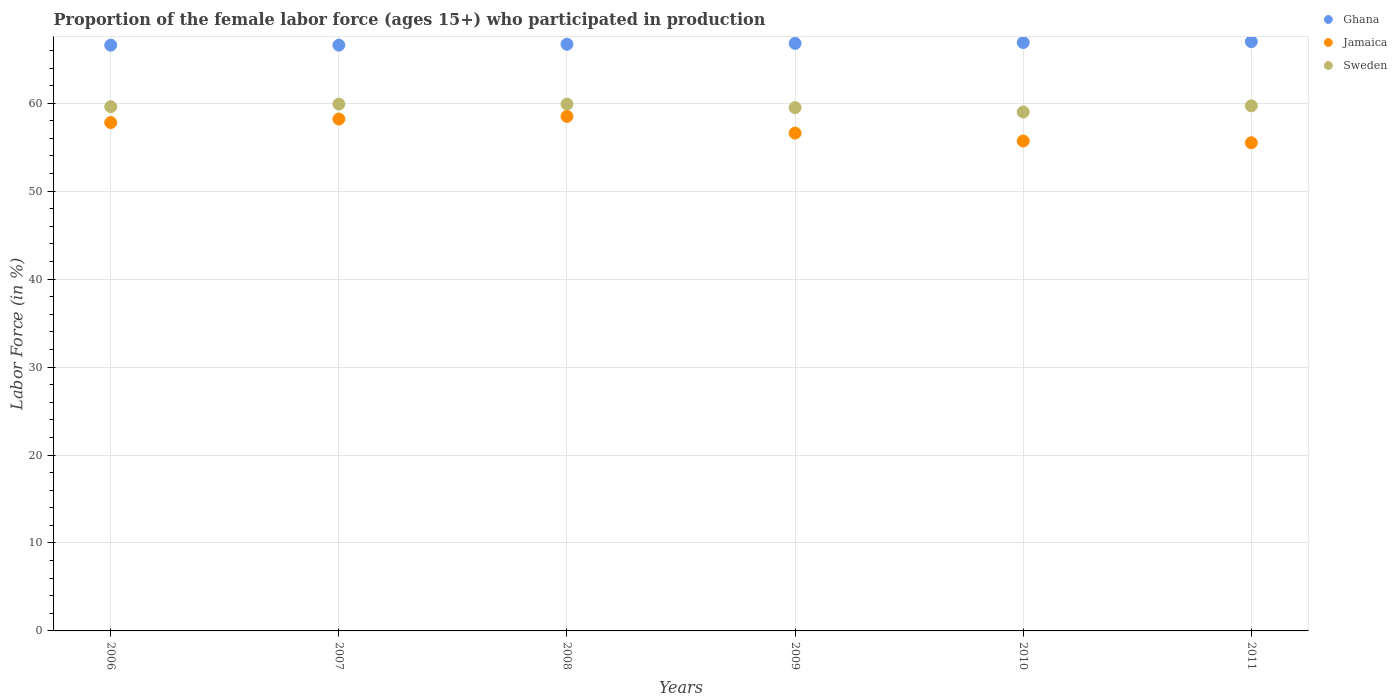Is the number of dotlines equal to the number of legend labels?
Your answer should be very brief. Yes. Across all years, what is the maximum proportion of the female labor force who participated in production in Jamaica?
Provide a short and direct response. 58.5. Across all years, what is the minimum proportion of the female labor force who participated in production in Sweden?
Provide a succinct answer. 59. What is the total proportion of the female labor force who participated in production in Ghana in the graph?
Your response must be concise. 400.6. What is the difference between the proportion of the female labor force who participated in production in Ghana in 2006 and that in 2011?
Give a very brief answer. -0.4. What is the difference between the proportion of the female labor force who participated in production in Jamaica in 2010 and the proportion of the female labor force who participated in production in Ghana in 2008?
Keep it short and to the point. -11. What is the average proportion of the female labor force who participated in production in Sweden per year?
Keep it short and to the point. 59.6. In the year 2009, what is the difference between the proportion of the female labor force who participated in production in Sweden and proportion of the female labor force who participated in production in Ghana?
Give a very brief answer. -7.3. What is the ratio of the proportion of the female labor force who participated in production in Ghana in 2006 to that in 2008?
Give a very brief answer. 1. Is the proportion of the female labor force who participated in production in Ghana in 2006 less than that in 2008?
Ensure brevity in your answer.  Yes. Is the difference between the proportion of the female labor force who participated in production in Sweden in 2008 and 2011 greater than the difference between the proportion of the female labor force who participated in production in Ghana in 2008 and 2011?
Offer a terse response. Yes. What is the difference between the highest and the second highest proportion of the female labor force who participated in production in Jamaica?
Make the answer very short. 0.3. In how many years, is the proportion of the female labor force who participated in production in Ghana greater than the average proportion of the female labor force who participated in production in Ghana taken over all years?
Give a very brief answer. 3. Is it the case that in every year, the sum of the proportion of the female labor force who participated in production in Sweden and proportion of the female labor force who participated in production in Ghana  is greater than the proportion of the female labor force who participated in production in Jamaica?
Your response must be concise. Yes. Does the proportion of the female labor force who participated in production in Sweden monotonically increase over the years?
Keep it short and to the point. No. Is the proportion of the female labor force who participated in production in Ghana strictly greater than the proportion of the female labor force who participated in production in Sweden over the years?
Keep it short and to the point. Yes. Is the proportion of the female labor force who participated in production in Sweden strictly less than the proportion of the female labor force who participated in production in Ghana over the years?
Provide a succinct answer. Yes. How many years are there in the graph?
Your answer should be compact. 6. Are the values on the major ticks of Y-axis written in scientific E-notation?
Provide a short and direct response. No. Does the graph contain any zero values?
Make the answer very short. No. Does the graph contain grids?
Offer a very short reply. Yes. Where does the legend appear in the graph?
Give a very brief answer. Top right. How many legend labels are there?
Provide a short and direct response. 3. What is the title of the graph?
Provide a succinct answer. Proportion of the female labor force (ages 15+) who participated in production. Does "World" appear as one of the legend labels in the graph?
Offer a very short reply. No. What is the Labor Force (in %) of Ghana in 2006?
Give a very brief answer. 66.6. What is the Labor Force (in %) in Jamaica in 2006?
Provide a short and direct response. 57.8. What is the Labor Force (in %) of Sweden in 2006?
Make the answer very short. 59.6. What is the Labor Force (in %) in Ghana in 2007?
Keep it short and to the point. 66.6. What is the Labor Force (in %) of Jamaica in 2007?
Provide a short and direct response. 58.2. What is the Labor Force (in %) in Sweden in 2007?
Your response must be concise. 59.9. What is the Labor Force (in %) in Ghana in 2008?
Your answer should be compact. 66.7. What is the Labor Force (in %) of Jamaica in 2008?
Give a very brief answer. 58.5. What is the Labor Force (in %) in Sweden in 2008?
Offer a very short reply. 59.9. What is the Labor Force (in %) of Ghana in 2009?
Provide a succinct answer. 66.8. What is the Labor Force (in %) in Jamaica in 2009?
Keep it short and to the point. 56.6. What is the Labor Force (in %) in Sweden in 2009?
Offer a very short reply. 59.5. What is the Labor Force (in %) of Ghana in 2010?
Offer a terse response. 66.9. What is the Labor Force (in %) of Jamaica in 2010?
Offer a very short reply. 55.7. What is the Labor Force (in %) of Sweden in 2010?
Your answer should be very brief. 59. What is the Labor Force (in %) of Ghana in 2011?
Give a very brief answer. 67. What is the Labor Force (in %) of Jamaica in 2011?
Make the answer very short. 55.5. What is the Labor Force (in %) of Sweden in 2011?
Keep it short and to the point. 59.7. Across all years, what is the maximum Labor Force (in %) in Ghana?
Your answer should be compact. 67. Across all years, what is the maximum Labor Force (in %) of Jamaica?
Give a very brief answer. 58.5. Across all years, what is the maximum Labor Force (in %) in Sweden?
Your response must be concise. 59.9. Across all years, what is the minimum Labor Force (in %) in Ghana?
Keep it short and to the point. 66.6. Across all years, what is the minimum Labor Force (in %) of Jamaica?
Your response must be concise. 55.5. What is the total Labor Force (in %) of Ghana in the graph?
Provide a succinct answer. 400.6. What is the total Labor Force (in %) in Jamaica in the graph?
Your answer should be very brief. 342.3. What is the total Labor Force (in %) of Sweden in the graph?
Make the answer very short. 357.6. What is the difference between the Labor Force (in %) of Ghana in 2006 and that in 2008?
Your answer should be very brief. -0.1. What is the difference between the Labor Force (in %) of Ghana in 2006 and that in 2010?
Ensure brevity in your answer.  -0.3. What is the difference between the Labor Force (in %) in Jamaica in 2006 and that in 2010?
Ensure brevity in your answer.  2.1. What is the difference between the Labor Force (in %) of Sweden in 2006 and that in 2010?
Keep it short and to the point. 0.6. What is the difference between the Labor Force (in %) in Ghana in 2007 and that in 2008?
Your response must be concise. -0.1. What is the difference between the Labor Force (in %) in Jamaica in 2007 and that in 2008?
Your answer should be compact. -0.3. What is the difference between the Labor Force (in %) in Sweden in 2007 and that in 2008?
Offer a very short reply. 0. What is the difference between the Labor Force (in %) of Ghana in 2007 and that in 2010?
Your answer should be very brief. -0.3. What is the difference between the Labor Force (in %) in Jamaica in 2008 and that in 2009?
Provide a short and direct response. 1.9. What is the difference between the Labor Force (in %) of Sweden in 2008 and that in 2009?
Offer a very short reply. 0.4. What is the difference between the Labor Force (in %) in Sweden in 2008 and that in 2010?
Keep it short and to the point. 0.9. What is the difference between the Labor Force (in %) of Ghana in 2008 and that in 2011?
Keep it short and to the point. -0.3. What is the difference between the Labor Force (in %) in Jamaica in 2008 and that in 2011?
Offer a very short reply. 3. What is the difference between the Labor Force (in %) in Sweden in 2008 and that in 2011?
Provide a short and direct response. 0.2. What is the difference between the Labor Force (in %) in Ghana in 2009 and that in 2010?
Offer a terse response. -0.1. What is the difference between the Labor Force (in %) of Sweden in 2009 and that in 2010?
Offer a terse response. 0.5. What is the difference between the Labor Force (in %) in Ghana in 2009 and that in 2011?
Offer a terse response. -0.2. What is the difference between the Labor Force (in %) of Ghana in 2010 and that in 2011?
Keep it short and to the point. -0.1. What is the difference between the Labor Force (in %) of Ghana in 2006 and the Labor Force (in %) of Jamaica in 2008?
Keep it short and to the point. 8.1. What is the difference between the Labor Force (in %) in Jamaica in 2006 and the Labor Force (in %) in Sweden in 2008?
Offer a very short reply. -2.1. What is the difference between the Labor Force (in %) in Ghana in 2006 and the Labor Force (in %) in Jamaica in 2009?
Offer a very short reply. 10. What is the difference between the Labor Force (in %) of Ghana in 2006 and the Labor Force (in %) of Sweden in 2009?
Give a very brief answer. 7.1. What is the difference between the Labor Force (in %) of Ghana in 2006 and the Labor Force (in %) of Jamaica in 2011?
Your response must be concise. 11.1. What is the difference between the Labor Force (in %) in Ghana in 2006 and the Labor Force (in %) in Sweden in 2011?
Provide a succinct answer. 6.9. What is the difference between the Labor Force (in %) in Jamaica in 2006 and the Labor Force (in %) in Sweden in 2011?
Provide a short and direct response. -1.9. What is the difference between the Labor Force (in %) of Ghana in 2007 and the Labor Force (in %) of Sweden in 2008?
Provide a short and direct response. 6.7. What is the difference between the Labor Force (in %) of Ghana in 2007 and the Labor Force (in %) of Jamaica in 2009?
Give a very brief answer. 10. What is the difference between the Labor Force (in %) of Jamaica in 2007 and the Labor Force (in %) of Sweden in 2009?
Give a very brief answer. -1.3. What is the difference between the Labor Force (in %) of Jamaica in 2007 and the Labor Force (in %) of Sweden in 2010?
Your answer should be compact. -0.8. What is the difference between the Labor Force (in %) in Ghana in 2007 and the Labor Force (in %) in Jamaica in 2011?
Provide a succinct answer. 11.1. What is the difference between the Labor Force (in %) in Ghana in 2007 and the Labor Force (in %) in Sweden in 2011?
Offer a very short reply. 6.9. What is the difference between the Labor Force (in %) of Ghana in 2008 and the Labor Force (in %) of Sweden in 2009?
Provide a succinct answer. 7.2. What is the difference between the Labor Force (in %) in Ghana in 2008 and the Labor Force (in %) in Jamaica in 2010?
Ensure brevity in your answer.  11. What is the difference between the Labor Force (in %) in Ghana in 2008 and the Labor Force (in %) in Sweden in 2010?
Offer a very short reply. 7.7. What is the difference between the Labor Force (in %) of Ghana in 2008 and the Labor Force (in %) of Sweden in 2011?
Give a very brief answer. 7. What is the difference between the Labor Force (in %) of Ghana in 2009 and the Labor Force (in %) of Jamaica in 2010?
Make the answer very short. 11.1. What is the difference between the Labor Force (in %) in Ghana in 2009 and the Labor Force (in %) in Sweden in 2010?
Give a very brief answer. 7.8. What is the difference between the Labor Force (in %) in Ghana in 2009 and the Labor Force (in %) in Jamaica in 2011?
Offer a very short reply. 11.3. What is the difference between the Labor Force (in %) of Ghana in 2009 and the Labor Force (in %) of Sweden in 2011?
Your answer should be compact. 7.1. What is the average Labor Force (in %) in Ghana per year?
Offer a terse response. 66.77. What is the average Labor Force (in %) in Jamaica per year?
Keep it short and to the point. 57.05. What is the average Labor Force (in %) in Sweden per year?
Your response must be concise. 59.6. In the year 2006, what is the difference between the Labor Force (in %) in Ghana and Labor Force (in %) in Sweden?
Your answer should be compact. 7. In the year 2006, what is the difference between the Labor Force (in %) of Jamaica and Labor Force (in %) of Sweden?
Give a very brief answer. -1.8. In the year 2007, what is the difference between the Labor Force (in %) in Ghana and Labor Force (in %) in Jamaica?
Make the answer very short. 8.4. In the year 2007, what is the difference between the Labor Force (in %) in Jamaica and Labor Force (in %) in Sweden?
Offer a very short reply. -1.7. In the year 2008, what is the difference between the Labor Force (in %) of Ghana and Labor Force (in %) of Sweden?
Provide a succinct answer. 6.8. In the year 2008, what is the difference between the Labor Force (in %) of Jamaica and Labor Force (in %) of Sweden?
Your answer should be very brief. -1.4. In the year 2009, what is the difference between the Labor Force (in %) in Ghana and Labor Force (in %) in Jamaica?
Make the answer very short. 10.2. In the year 2009, what is the difference between the Labor Force (in %) of Ghana and Labor Force (in %) of Sweden?
Offer a terse response. 7.3. What is the ratio of the Labor Force (in %) of Ghana in 2006 to that in 2007?
Offer a terse response. 1. What is the ratio of the Labor Force (in %) in Jamaica in 2006 to that in 2007?
Offer a terse response. 0.99. What is the ratio of the Labor Force (in %) of Sweden in 2006 to that in 2007?
Provide a short and direct response. 0.99. What is the ratio of the Labor Force (in %) of Jamaica in 2006 to that in 2008?
Provide a short and direct response. 0.99. What is the ratio of the Labor Force (in %) of Ghana in 2006 to that in 2009?
Your response must be concise. 1. What is the ratio of the Labor Force (in %) of Jamaica in 2006 to that in 2009?
Your answer should be compact. 1.02. What is the ratio of the Labor Force (in %) of Sweden in 2006 to that in 2009?
Give a very brief answer. 1. What is the ratio of the Labor Force (in %) in Jamaica in 2006 to that in 2010?
Give a very brief answer. 1.04. What is the ratio of the Labor Force (in %) of Sweden in 2006 to that in 2010?
Give a very brief answer. 1.01. What is the ratio of the Labor Force (in %) in Ghana in 2006 to that in 2011?
Your response must be concise. 0.99. What is the ratio of the Labor Force (in %) in Jamaica in 2006 to that in 2011?
Your answer should be very brief. 1.04. What is the ratio of the Labor Force (in %) in Jamaica in 2007 to that in 2008?
Give a very brief answer. 0.99. What is the ratio of the Labor Force (in %) in Ghana in 2007 to that in 2009?
Provide a short and direct response. 1. What is the ratio of the Labor Force (in %) in Jamaica in 2007 to that in 2009?
Your answer should be compact. 1.03. What is the ratio of the Labor Force (in %) of Jamaica in 2007 to that in 2010?
Offer a terse response. 1.04. What is the ratio of the Labor Force (in %) in Sweden in 2007 to that in 2010?
Give a very brief answer. 1.02. What is the ratio of the Labor Force (in %) of Ghana in 2007 to that in 2011?
Give a very brief answer. 0.99. What is the ratio of the Labor Force (in %) of Jamaica in 2007 to that in 2011?
Your answer should be compact. 1.05. What is the ratio of the Labor Force (in %) of Ghana in 2008 to that in 2009?
Keep it short and to the point. 1. What is the ratio of the Labor Force (in %) in Jamaica in 2008 to that in 2009?
Ensure brevity in your answer.  1.03. What is the ratio of the Labor Force (in %) in Ghana in 2008 to that in 2010?
Ensure brevity in your answer.  1. What is the ratio of the Labor Force (in %) of Jamaica in 2008 to that in 2010?
Your answer should be very brief. 1.05. What is the ratio of the Labor Force (in %) of Sweden in 2008 to that in 2010?
Give a very brief answer. 1.02. What is the ratio of the Labor Force (in %) in Ghana in 2008 to that in 2011?
Offer a terse response. 1. What is the ratio of the Labor Force (in %) of Jamaica in 2008 to that in 2011?
Offer a very short reply. 1.05. What is the ratio of the Labor Force (in %) of Ghana in 2009 to that in 2010?
Your answer should be compact. 1. What is the ratio of the Labor Force (in %) of Jamaica in 2009 to that in 2010?
Keep it short and to the point. 1.02. What is the ratio of the Labor Force (in %) in Sweden in 2009 to that in 2010?
Give a very brief answer. 1.01. What is the ratio of the Labor Force (in %) of Ghana in 2009 to that in 2011?
Give a very brief answer. 1. What is the ratio of the Labor Force (in %) of Jamaica in 2009 to that in 2011?
Give a very brief answer. 1.02. What is the ratio of the Labor Force (in %) in Sweden in 2009 to that in 2011?
Ensure brevity in your answer.  1. What is the ratio of the Labor Force (in %) in Jamaica in 2010 to that in 2011?
Your answer should be very brief. 1. What is the ratio of the Labor Force (in %) of Sweden in 2010 to that in 2011?
Ensure brevity in your answer.  0.99. What is the difference between the highest and the second highest Labor Force (in %) of Sweden?
Your response must be concise. 0. What is the difference between the highest and the lowest Labor Force (in %) in Ghana?
Ensure brevity in your answer.  0.4. What is the difference between the highest and the lowest Labor Force (in %) in Jamaica?
Offer a terse response. 3. What is the difference between the highest and the lowest Labor Force (in %) of Sweden?
Your answer should be very brief. 0.9. 